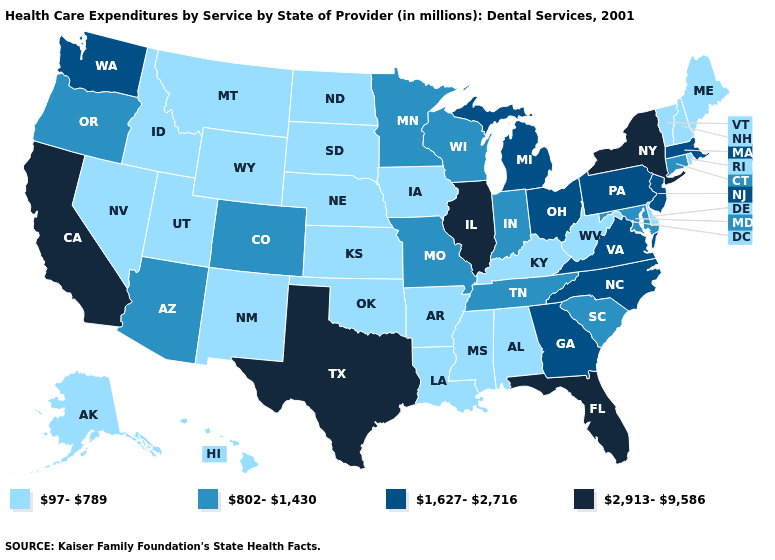How many symbols are there in the legend?
Short answer required. 4. What is the lowest value in states that border Colorado?
Short answer required. 97-789. Name the states that have a value in the range 1,627-2,716?
Write a very short answer. Georgia, Massachusetts, Michigan, New Jersey, North Carolina, Ohio, Pennsylvania, Virginia, Washington. Does Louisiana have the highest value in the South?
Be succinct. No. What is the value of Connecticut?
Short answer required. 802-1,430. Does New York have the lowest value in the USA?
Keep it brief. No. Which states have the highest value in the USA?
Short answer required. California, Florida, Illinois, New York, Texas. What is the value of Missouri?
Keep it brief. 802-1,430. Among the states that border Missouri , which have the highest value?
Answer briefly. Illinois. What is the value of Kansas?
Write a very short answer. 97-789. Is the legend a continuous bar?
Quick response, please. No. Which states have the lowest value in the USA?
Concise answer only. Alabama, Alaska, Arkansas, Delaware, Hawaii, Idaho, Iowa, Kansas, Kentucky, Louisiana, Maine, Mississippi, Montana, Nebraska, Nevada, New Hampshire, New Mexico, North Dakota, Oklahoma, Rhode Island, South Dakota, Utah, Vermont, West Virginia, Wyoming. What is the value of Michigan?
Be succinct. 1,627-2,716. What is the value of Pennsylvania?
Answer briefly. 1,627-2,716. Name the states that have a value in the range 802-1,430?
Give a very brief answer. Arizona, Colorado, Connecticut, Indiana, Maryland, Minnesota, Missouri, Oregon, South Carolina, Tennessee, Wisconsin. 